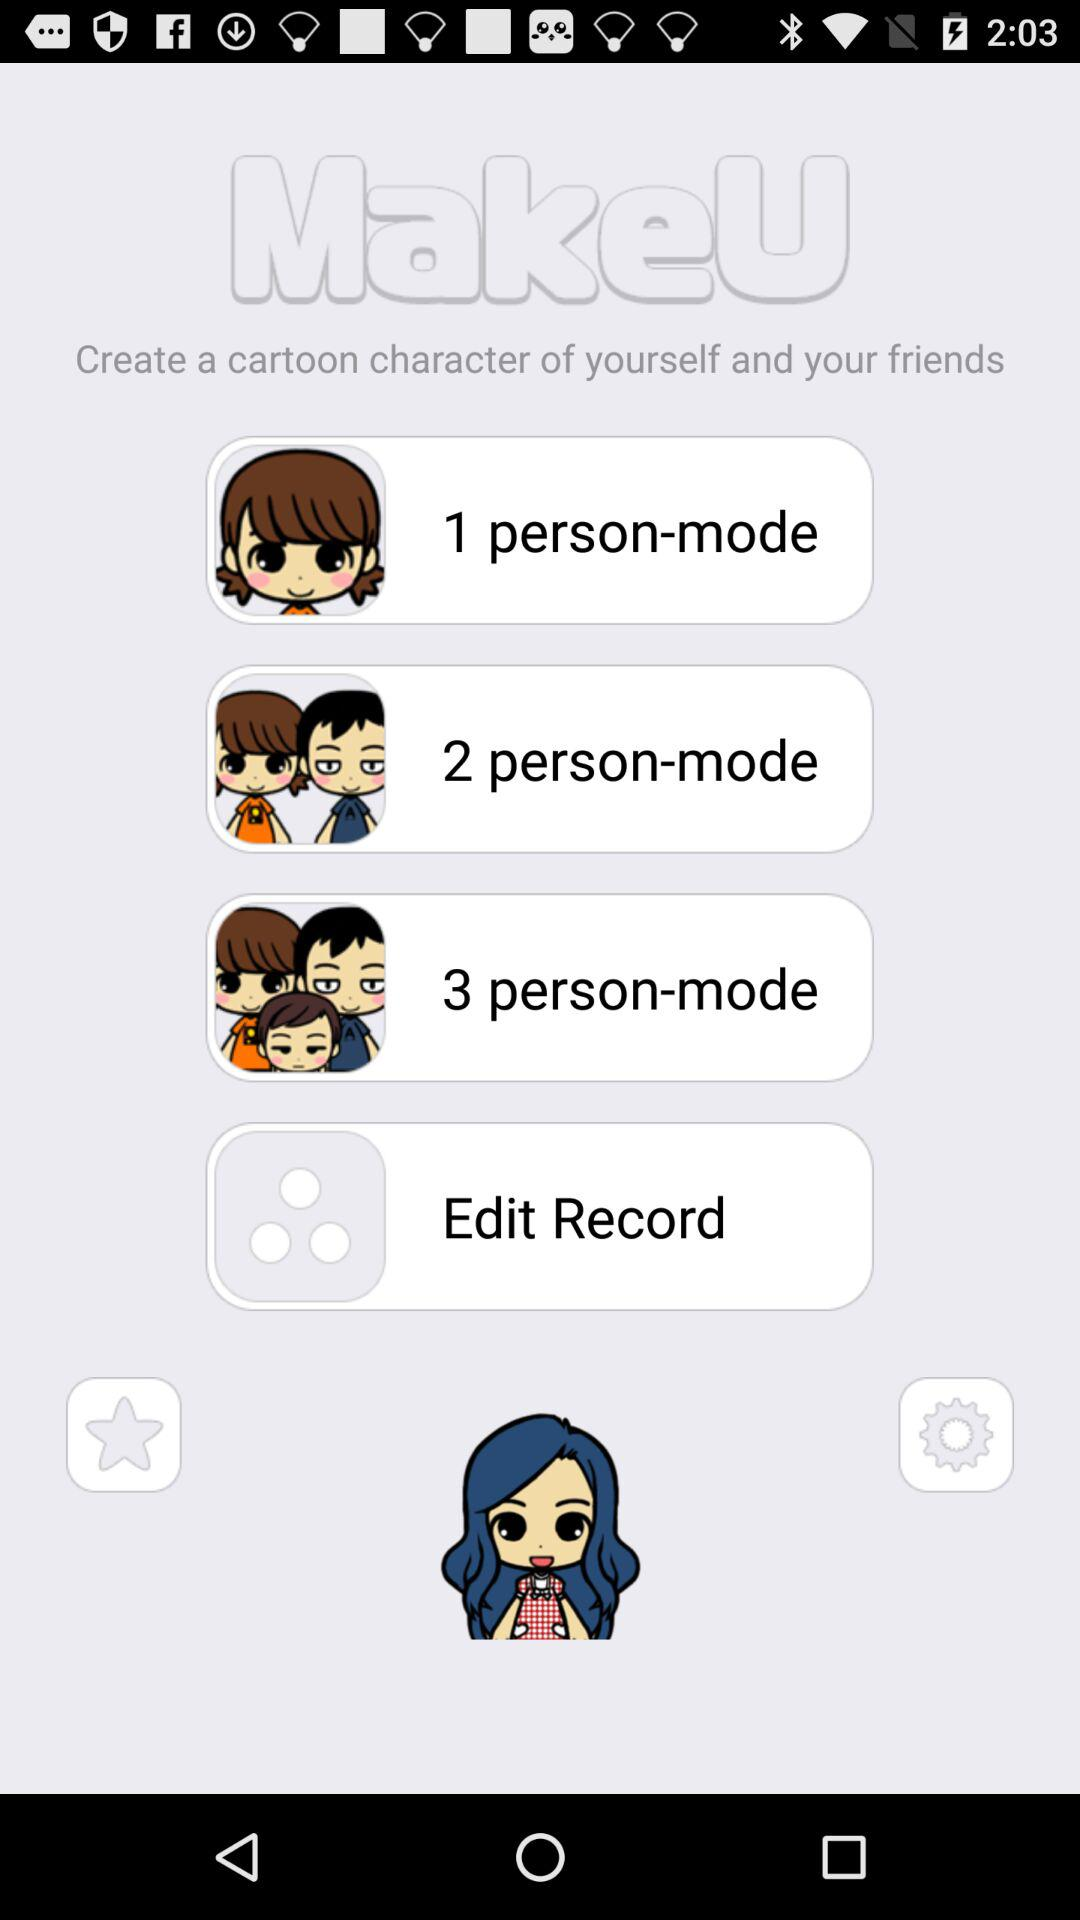How many person-modes are available?
Answer the question using a single word or phrase. 3 